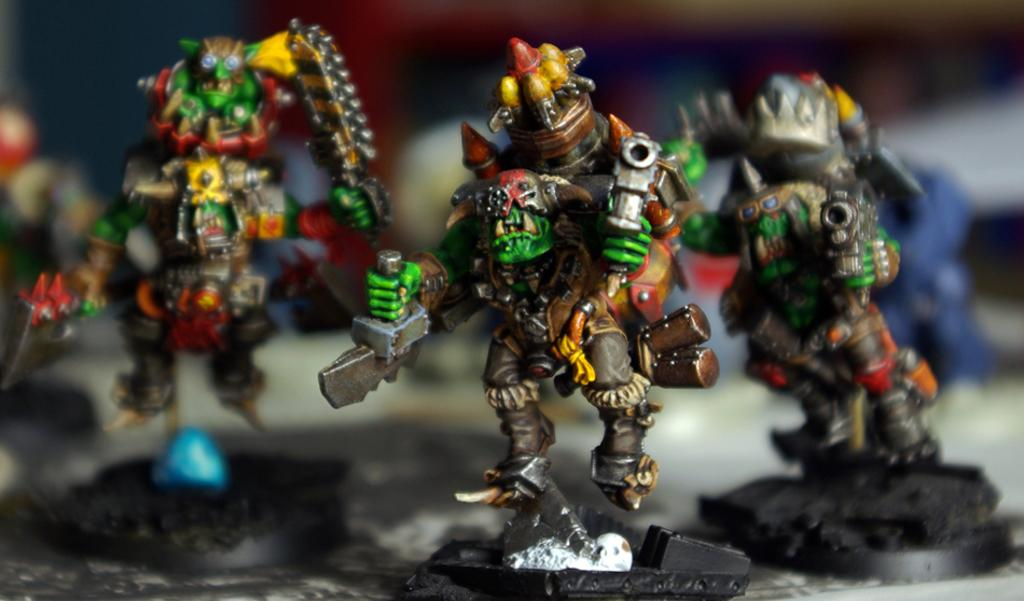What objects are present in the image? There are toys in the image. Can you describe the colors of the toys? The toys have various colors, including green, black, red, brown, orange, silver, and yellow. What can be observed about the background of the image? The background of the image is blurry. What type of music can be heard playing in the background of the image? There is no music present in the image, as it only features toys and a blurry background. 